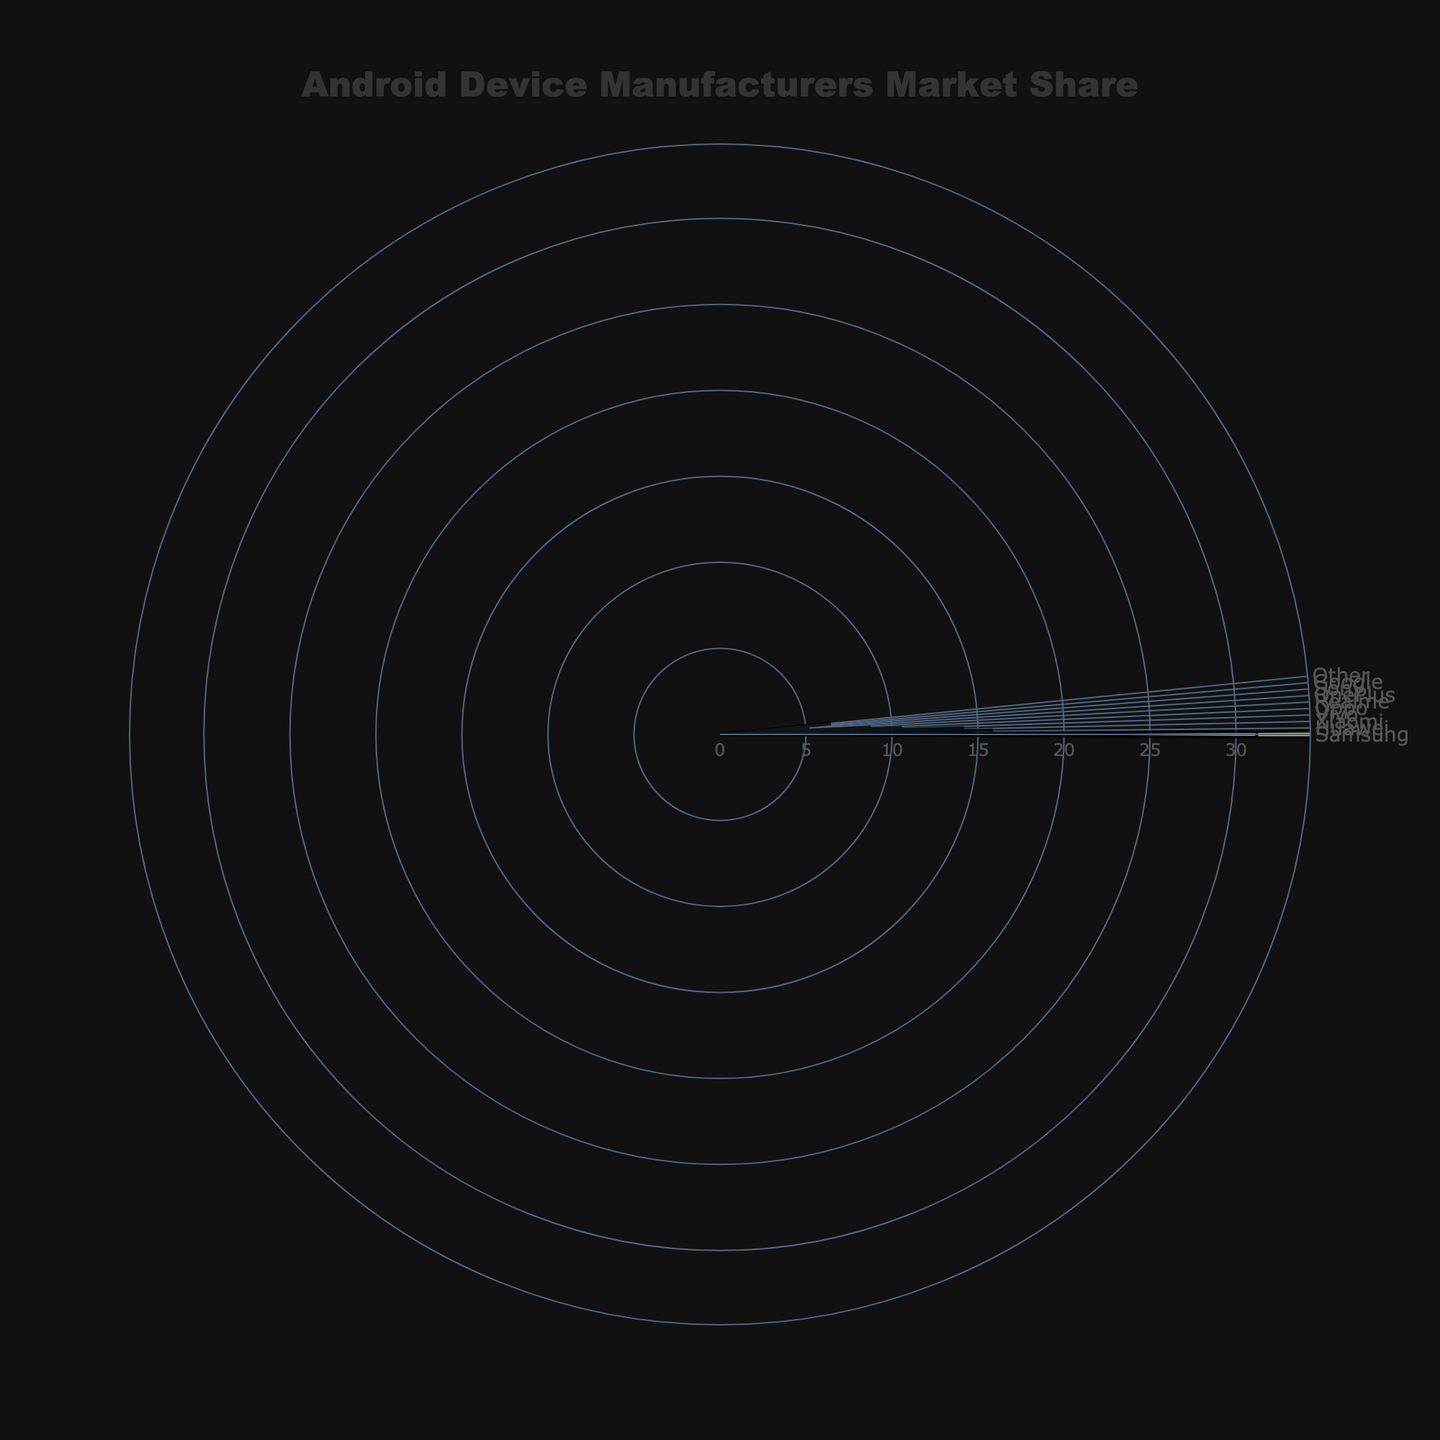What's the title of the chart? The title is usually located at the top of the chart and gives an idea of what the chart is about.
Answer: Android Device Manufacturers Market Share Which manufacturer has the largest market share? By looking at the manufacturer with the longest bar in the chart, it's clear which one has the largest share.
Answer: Samsung What is the market share of the manufacturer with the smallest representation? The bar length and the percentage value for the smallest segment will give the market share for that manufacturer.
Answer: Google, with 2.3% How many manufacturers have a market share greater than 10%? Count the number of bars that exceed the 10% mark.
Answer: Four (Samsung, Huawei, Xiaomi, and Vivo) Which manufacturers have market shares between 5% and 10%? Identify the bars that fall within this range by checking the length and values of each.
Answer: Oppo, Realme What is the total market share of Samsung, Huawei, and Xiaomi combined? Add the market shares of Samsung (31.2%), Huawei (15.8%), and Xiaomi (14.1%). Calculation: 31.2 + 15.8 + 14.1 = 61.1%
Answer: 61.1% Which manufacturer has a market share closest to 5%? Find the manufacturer whose bar length and value are closest to 5%.
Answer: Realme How much more market share does Samsung have compared to Huawei? Subtract Huawei's market share from Samsung's. Calculation: 31.2% - 15.8% = 15.4%
Answer: 15.4% What is the average market share of all manufacturers shown in the chart? Sum all the market share values and divide by the number of manufacturers. Calculation: (31.2 + 15.8 + 14.1 + 10.5 + 8.7 + 5.1 + 3.2 + 2.7 + 2.3 + 6.4) / 10 = 10.0%
Answer: 10.0% How does Google's market share compare to Sony's? Compare the market share values directly, noting that Sony has a slightly higher percentage.
Answer: Sony has a slightly higher market share than Google 